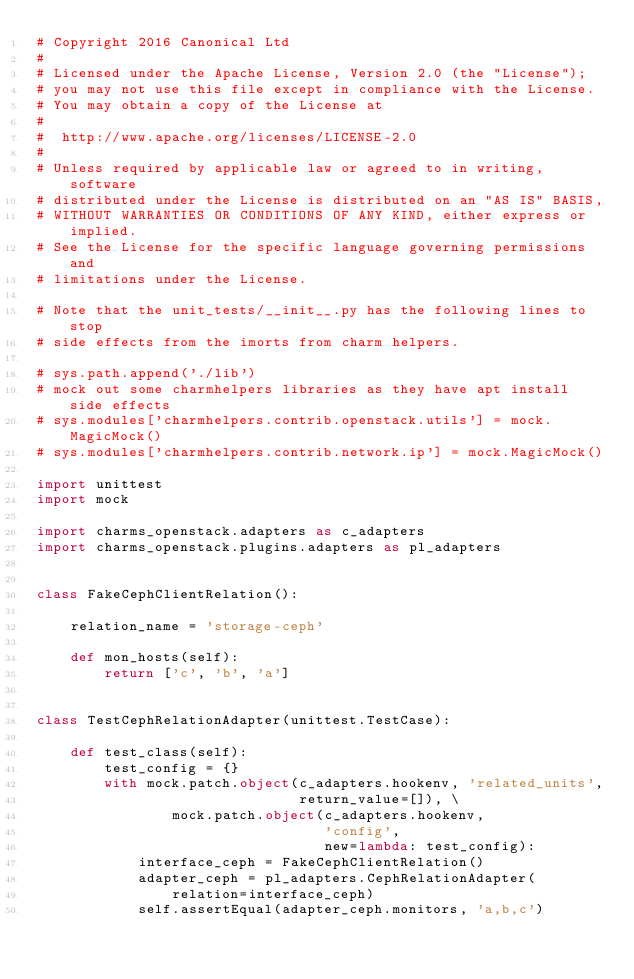<code> <loc_0><loc_0><loc_500><loc_500><_Python_># Copyright 2016 Canonical Ltd
#
# Licensed under the Apache License, Version 2.0 (the "License");
# you may not use this file except in compliance with the License.
# You may obtain a copy of the License at
#
#  http://www.apache.org/licenses/LICENSE-2.0
#
# Unless required by applicable law or agreed to in writing, software
# distributed under the License is distributed on an "AS IS" BASIS,
# WITHOUT WARRANTIES OR CONDITIONS OF ANY KIND, either express or implied.
# See the License for the specific language governing permissions and
# limitations under the License.

# Note that the unit_tests/__init__.py has the following lines to stop
# side effects from the imorts from charm helpers.

# sys.path.append('./lib')
# mock out some charmhelpers libraries as they have apt install side effects
# sys.modules['charmhelpers.contrib.openstack.utils'] = mock.MagicMock()
# sys.modules['charmhelpers.contrib.network.ip'] = mock.MagicMock()

import unittest
import mock

import charms_openstack.adapters as c_adapters
import charms_openstack.plugins.adapters as pl_adapters


class FakeCephClientRelation():

    relation_name = 'storage-ceph'

    def mon_hosts(self):
        return ['c', 'b', 'a']


class TestCephRelationAdapter(unittest.TestCase):

    def test_class(self):
        test_config = {}
        with mock.patch.object(c_adapters.hookenv, 'related_units',
                               return_value=[]), \
                mock.patch.object(c_adapters.hookenv,
                                  'config',
                                  new=lambda: test_config):
            interface_ceph = FakeCephClientRelation()
            adapter_ceph = pl_adapters.CephRelationAdapter(
                relation=interface_ceph)
            self.assertEqual(adapter_ceph.monitors, 'a,b,c')
</code> 